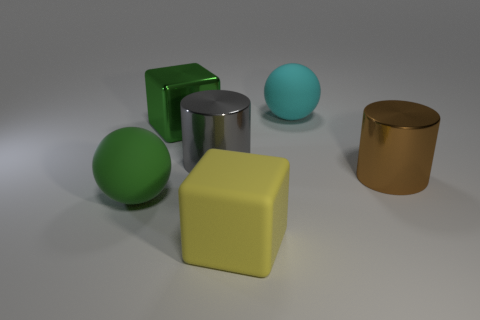Can you tell me about the textures and materials of the objects shown? Certainly! From left to right, we have a matte green sphere, a shiny green cube, a shiny metallic-looking cylinder, a blue sphere with a matte finish, and a matte gold-colored cylinder. These offer a variety of textures, from the smooth sheen of the shiny objects to the more subdued matte finishes. 